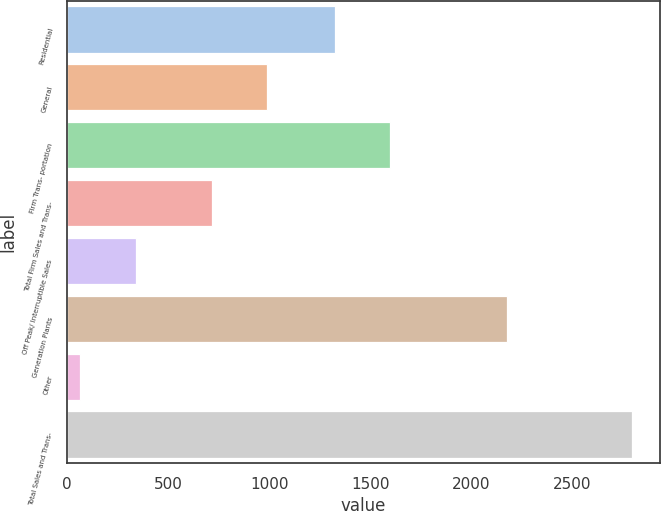<chart> <loc_0><loc_0><loc_500><loc_500><bar_chart><fcel>Residential<fcel>General<fcel>Firm Trans- portation<fcel>Total Firm Sales and Trans-<fcel>Off Peak/ Interruptible Sales<fcel>Generation Plants<fcel>Other<fcel>Total Sales and Trans-<nl><fcel>1323<fcel>989.8<fcel>1595.8<fcel>717<fcel>338.8<fcel>2174<fcel>66<fcel>2794<nl></chart> 